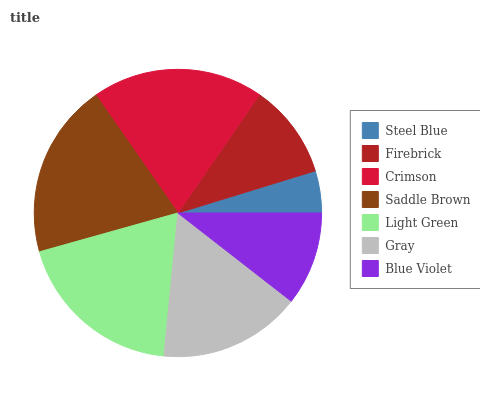Is Steel Blue the minimum?
Answer yes or no. Yes. Is Saddle Brown the maximum?
Answer yes or no. Yes. Is Firebrick the minimum?
Answer yes or no. No. Is Firebrick the maximum?
Answer yes or no. No. Is Firebrick greater than Steel Blue?
Answer yes or no. Yes. Is Steel Blue less than Firebrick?
Answer yes or no. Yes. Is Steel Blue greater than Firebrick?
Answer yes or no. No. Is Firebrick less than Steel Blue?
Answer yes or no. No. Is Gray the high median?
Answer yes or no. Yes. Is Gray the low median?
Answer yes or no. Yes. Is Saddle Brown the high median?
Answer yes or no. No. Is Firebrick the low median?
Answer yes or no. No. 